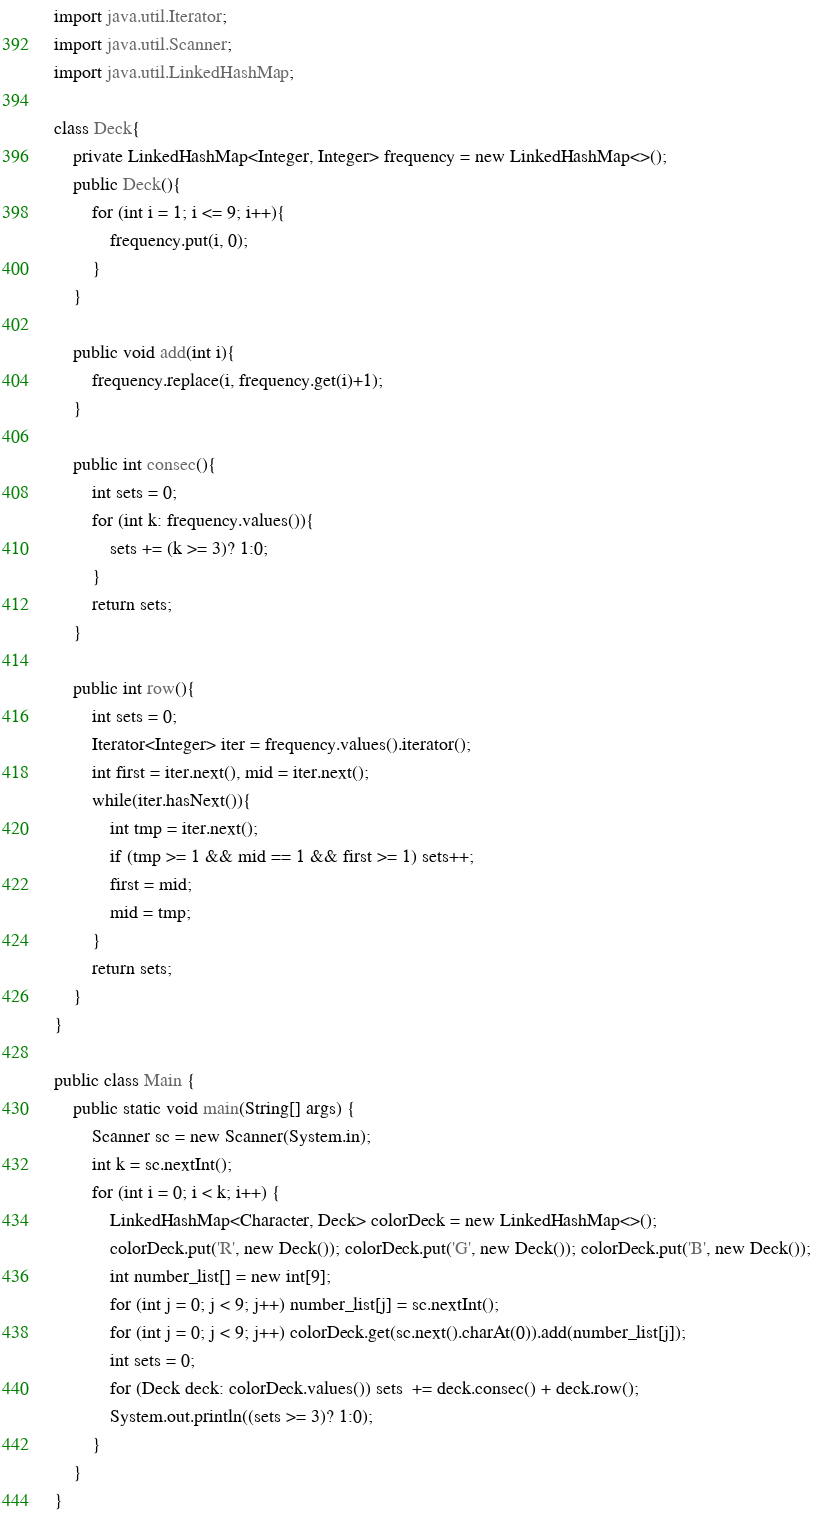Convert code to text. <code><loc_0><loc_0><loc_500><loc_500><_Java_>import java.util.Iterator;
import java.util.Scanner;
import java.util.LinkedHashMap;

class Deck{
    private LinkedHashMap<Integer, Integer> frequency = new LinkedHashMap<>();
    public Deck(){
        for (int i = 1; i <= 9; i++){
            frequency.put(i, 0);
        }
    }

    public void add(int i){
        frequency.replace(i, frequency.get(i)+1);
    }

    public int consec(){
        int sets = 0;
        for (int k: frequency.values()){
            sets += (k >= 3)? 1:0;
        }
        return sets;
    }

    public int row(){
        int sets = 0;
        Iterator<Integer> iter = frequency.values().iterator();
        int first = iter.next(), mid = iter.next();
        while(iter.hasNext()){
            int tmp = iter.next();
            if (tmp >= 1 && mid == 1 && first >= 1) sets++;
            first = mid;
            mid = tmp;
        }
        return sets;
    }
}

public class Main {
    public static void main(String[] args) {
        Scanner sc = new Scanner(System.in);
        int k = sc.nextInt();
        for (int i = 0; i < k; i++) {
            LinkedHashMap<Character, Deck> colorDeck = new LinkedHashMap<>();
            colorDeck.put('R', new Deck()); colorDeck.put('G', new Deck()); colorDeck.put('B', new Deck());
            int number_list[] = new int[9];
            for (int j = 0; j < 9; j++) number_list[j] = sc.nextInt();
            for (int j = 0; j < 9; j++) colorDeck.get(sc.next().charAt(0)).add(number_list[j]);
            int sets = 0;
            for (Deck deck: colorDeck.values()) sets  += deck.consec() + deck.row();
            System.out.println((sets >= 3)? 1:0);
        }
    }
}</code> 